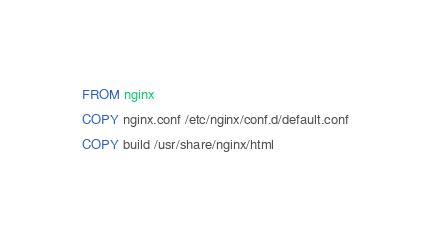Convert code to text. <code><loc_0><loc_0><loc_500><loc_500><_Dockerfile_>FROM nginx
COPY nginx.conf /etc/nginx/conf.d/default.conf
COPY build /usr/share/nginx/html
</code> 